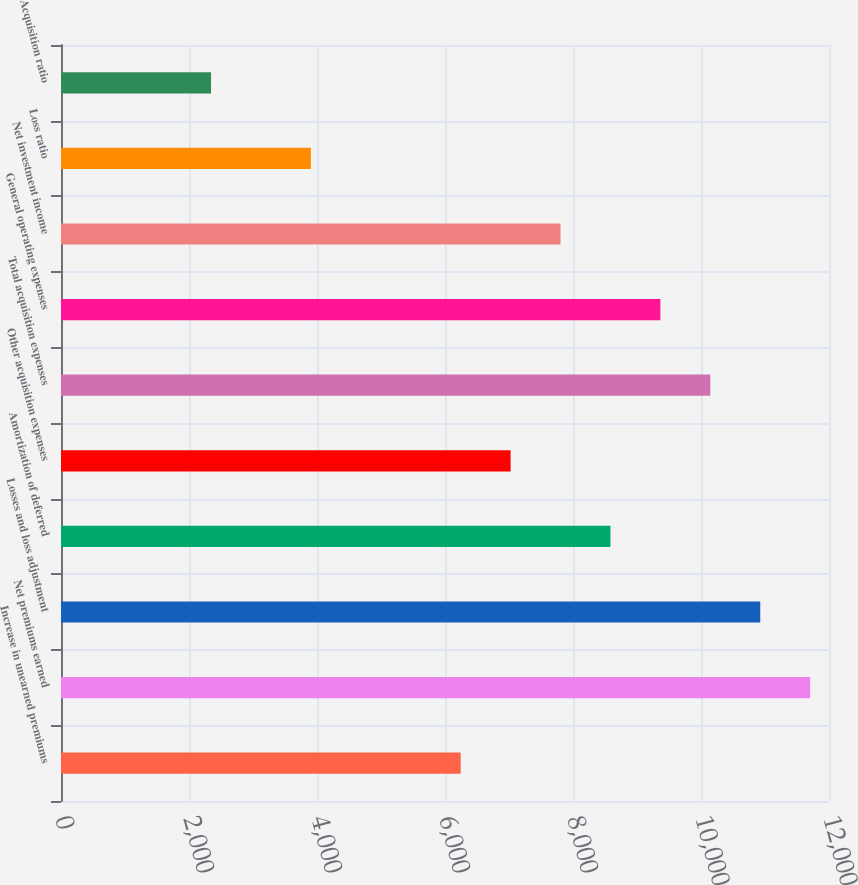<chart> <loc_0><loc_0><loc_500><loc_500><bar_chart><fcel>Increase in unearned premiums<fcel>Net premiums earned<fcel>Losses and loss adjustment<fcel>Amortization of deferred<fcel>Other acquisition expenses<fcel>Total acquisition expenses<fcel>General operating expenses<fcel>Net investment income<fcel>Loss ratio<fcel>Acquisition ratio<nl><fcel>6244.76<fcel>11705.6<fcel>10925.5<fcel>8585.12<fcel>7024.88<fcel>10145.4<fcel>9365.24<fcel>7805<fcel>3904.4<fcel>2344.16<nl></chart> 